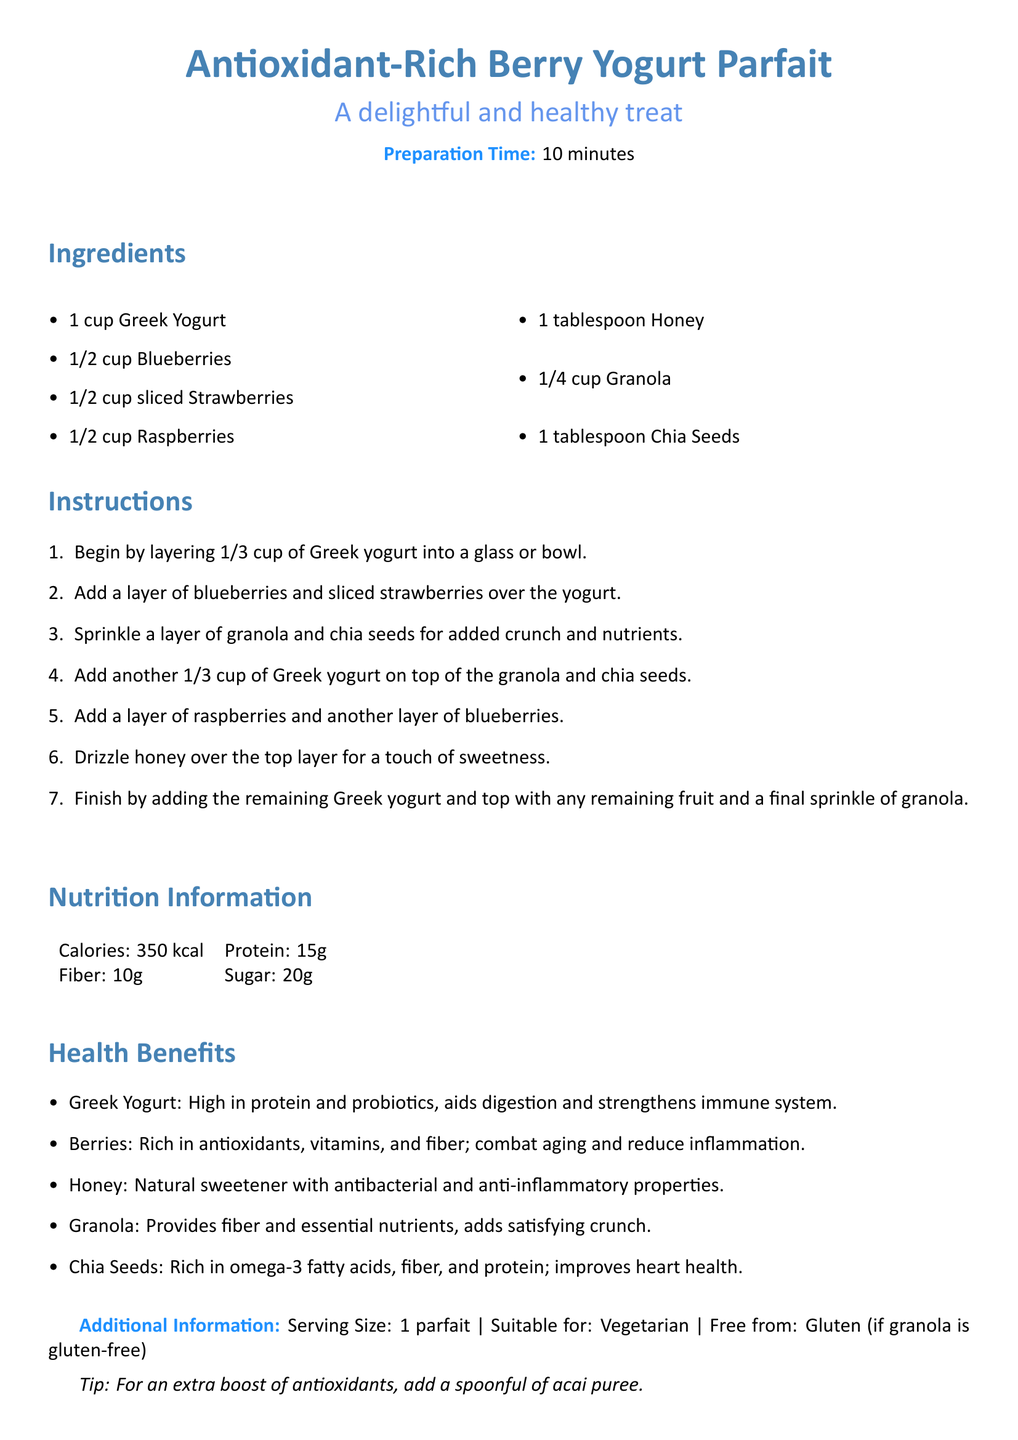What is the preparation time? The preparation time for the parfait is stated in the document as 10 minutes.
Answer: 10 minutes How many cups of Greek yogurt are needed? The document specifies that 1 cup of Greek yogurt is required for the recipe.
Answer: 1 cup What fruits are included in the parfait? The recipe lists blueberries, strawberries, and raspberries as the fruits included.
Answer: Blueberries, strawberries, raspberries What is a health benefit of chia seeds? The document states that chia seeds are rich in omega-3 fatty acids, fiber, and protein, which improve heart health.
Answer: Improves heart health What is one of the sweeteners used in the recipe? Honey is mentioned as the natural sweetener for the parfait.
Answer: Honey What is the serving size? The serving size for the parfait is clearly stated in the extra information section of the document.
Answer: 1 parfait What nutritional component does granola provide? The document mentions that granola provides fiber and essential nutrients.
Answer: Fiber How many grams of protein are in the parfait? The nutrition information section lists the protein content as 15 grams.
Answer: 15g 